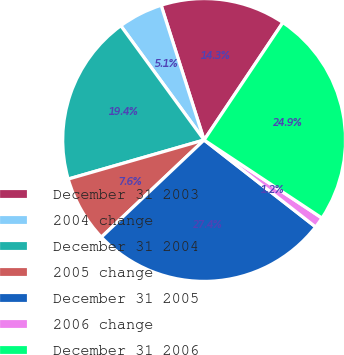<chart> <loc_0><loc_0><loc_500><loc_500><pie_chart><fcel>December 31 2003<fcel>2004 change<fcel>December 31 2004<fcel>2005 change<fcel>December 31 2005<fcel>2006 change<fcel>December 31 2006<nl><fcel>14.32%<fcel>5.11%<fcel>19.43%<fcel>7.6%<fcel>27.4%<fcel>1.23%<fcel>24.91%<nl></chart> 